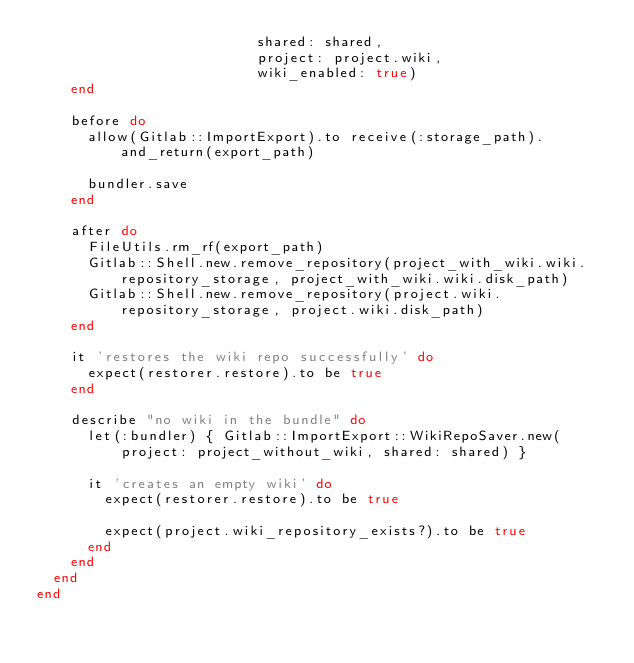<code> <loc_0><loc_0><loc_500><loc_500><_Ruby_>                          shared: shared,
                          project: project.wiki,
                          wiki_enabled: true)
    end

    before do
      allow(Gitlab::ImportExport).to receive(:storage_path).and_return(export_path)

      bundler.save
    end

    after do
      FileUtils.rm_rf(export_path)
      Gitlab::Shell.new.remove_repository(project_with_wiki.wiki.repository_storage, project_with_wiki.wiki.disk_path)
      Gitlab::Shell.new.remove_repository(project.wiki.repository_storage, project.wiki.disk_path)
    end

    it 'restores the wiki repo successfully' do
      expect(restorer.restore).to be true
    end

    describe "no wiki in the bundle" do
      let(:bundler) { Gitlab::ImportExport::WikiRepoSaver.new(project: project_without_wiki, shared: shared) }

      it 'creates an empty wiki' do
        expect(restorer.restore).to be true

        expect(project.wiki_repository_exists?).to be true
      end
    end
  end
end
</code> 